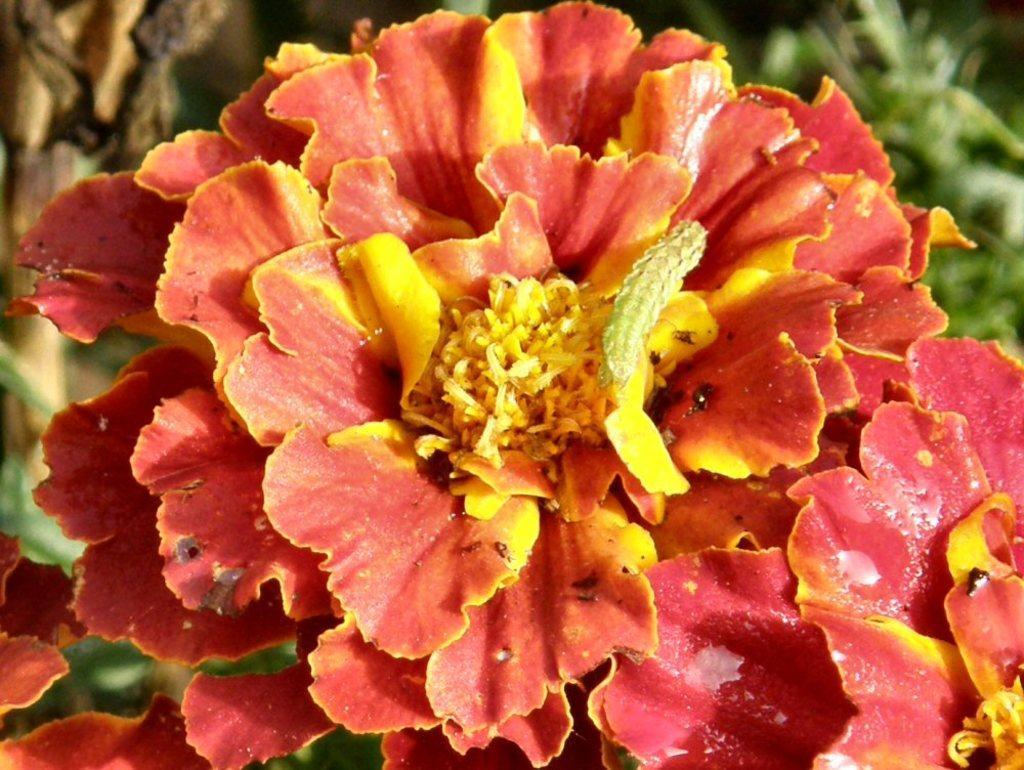Describe this image in one or two sentences. In this image we can see worm on the flower. 